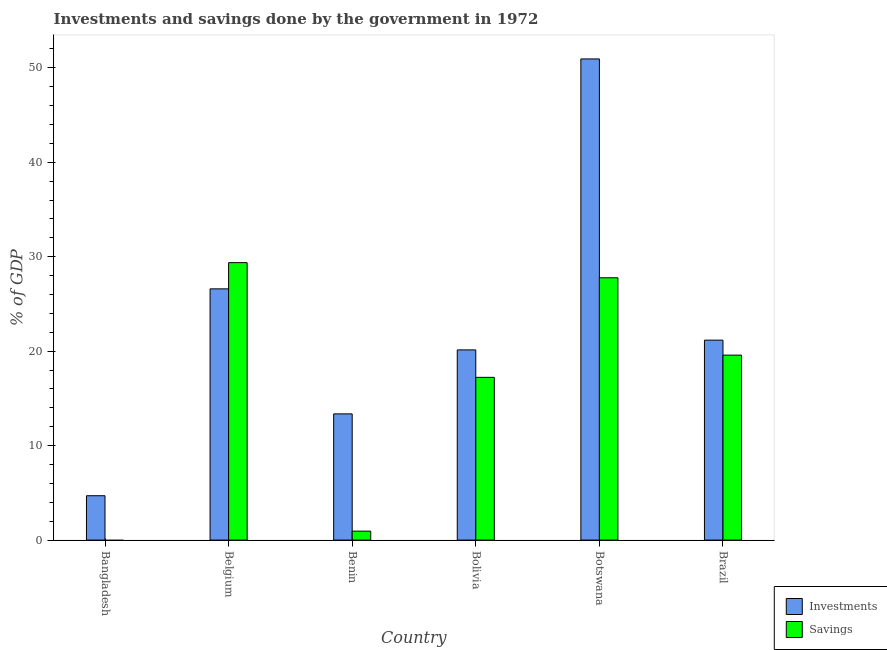How many different coloured bars are there?
Keep it short and to the point. 2. Are the number of bars per tick equal to the number of legend labels?
Your answer should be very brief. No. How many bars are there on the 4th tick from the left?
Keep it short and to the point. 2. How many bars are there on the 1st tick from the right?
Give a very brief answer. 2. What is the label of the 1st group of bars from the left?
Your answer should be compact. Bangladesh. What is the savings of government in Bolivia?
Offer a terse response. 17.23. Across all countries, what is the maximum savings of government?
Provide a short and direct response. 29.38. Across all countries, what is the minimum savings of government?
Give a very brief answer. 0. In which country was the savings of government maximum?
Provide a short and direct response. Belgium. What is the total investments of government in the graph?
Ensure brevity in your answer.  136.91. What is the difference between the investments of government in Bangladesh and that in Belgium?
Provide a short and direct response. -21.9. What is the difference between the investments of government in Brazil and the savings of government in Benin?
Your response must be concise. 20.22. What is the average savings of government per country?
Provide a succinct answer. 15.82. What is the difference between the investments of government and savings of government in Botswana?
Provide a short and direct response. 23.17. What is the ratio of the investments of government in Bangladesh to that in Bolivia?
Offer a very short reply. 0.23. Is the savings of government in Bolivia less than that in Brazil?
Provide a succinct answer. Yes. What is the difference between the highest and the second highest investments of government?
Provide a short and direct response. 24.34. What is the difference between the highest and the lowest investments of government?
Make the answer very short. 46.25. In how many countries, is the savings of government greater than the average savings of government taken over all countries?
Keep it short and to the point. 4. Is the sum of the savings of government in Bolivia and Botswana greater than the maximum investments of government across all countries?
Offer a terse response. No. Are all the bars in the graph horizontal?
Your response must be concise. No. How many countries are there in the graph?
Your answer should be compact. 6. Are the values on the major ticks of Y-axis written in scientific E-notation?
Your answer should be compact. No. Does the graph contain any zero values?
Provide a succinct answer. Yes. Does the graph contain grids?
Make the answer very short. No. What is the title of the graph?
Ensure brevity in your answer.  Investments and savings done by the government in 1972. What is the label or title of the X-axis?
Your response must be concise. Country. What is the label or title of the Y-axis?
Provide a short and direct response. % of GDP. What is the % of GDP of Investments in Bangladesh?
Offer a very short reply. 4.7. What is the % of GDP in Investments in Belgium?
Your answer should be compact. 26.6. What is the % of GDP of Savings in Belgium?
Your answer should be very brief. 29.38. What is the % of GDP of Investments in Benin?
Give a very brief answer. 13.36. What is the % of GDP in Savings in Benin?
Give a very brief answer. 0.95. What is the % of GDP in Investments in Bolivia?
Make the answer very short. 20.14. What is the % of GDP of Savings in Bolivia?
Make the answer very short. 17.23. What is the % of GDP of Investments in Botswana?
Keep it short and to the point. 50.94. What is the % of GDP of Savings in Botswana?
Provide a short and direct response. 27.77. What is the % of GDP of Investments in Brazil?
Your answer should be compact. 21.17. What is the % of GDP of Savings in Brazil?
Keep it short and to the point. 19.59. Across all countries, what is the maximum % of GDP in Investments?
Provide a succinct answer. 50.94. Across all countries, what is the maximum % of GDP in Savings?
Keep it short and to the point. 29.38. Across all countries, what is the minimum % of GDP of Investments?
Offer a terse response. 4.7. Across all countries, what is the minimum % of GDP of Savings?
Your response must be concise. 0. What is the total % of GDP of Investments in the graph?
Ensure brevity in your answer.  136.91. What is the total % of GDP in Savings in the graph?
Your answer should be compact. 94.91. What is the difference between the % of GDP in Investments in Bangladesh and that in Belgium?
Keep it short and to the point. -21.9. What is the difference between the % of GDP in Investments in Bangladesh and that in Benin?
Keep it short and to the point. -8.67. What is the difference between the % of GDP of Investments in Bangladesh and that in Bolivia?
Your answer should be compact. -15.44. What is the difference between the % of GDP of Investments in Bangladesh and that in Botswana?
Make the answer very short. -46.25. What is the difference between the % of GDP in Investments in Bangladesh and that in Brazil?
Ensure brevity in your answer.  -16.47. What is the difference between the % of GDP in Investments in Belgium and that in Benin?
Your response must be concise. 13.24. What is the difference between the % of GDP in Savings in Belgium and that in Benin?
Offer a terse response. 28.43. What is the difference between the % of GDP in Investments in Belgium and that in Bolivia?
Ensure brevity in your answer.  6.46. What is the difference between the % of GDP of Savings in Belgium and that in Bolivia?
Offer a terse response. 12.15. What is the difference between the % of GDP in Investments in Belgium and that in Botswana?
Your answer should be very brief. -24.34. What is the difference between the % of GDP of Savings in Belgium and that in Botswana?
Give a very brief answer. 1.6. What is the difference between the % of GDP in Investments in Belgium and that in Brazil?
Offer a terse response. 5.43. What is the difference between the % of GDP in Savings in Belgium and that in Brazil?
Make the answer very short. 9.79. What is the difference between the % of GDP in Investments in Benin and that in Bolivia?
Your response must be concise. -6.77. What is the difference between the % of GDP in Savings in Benin and that in Bolivia?
Provide a short and direct response. -16.28. What is the difference between the % of GDP of Investments in Benin and that in Botswana?
Ensure brevity in your answer.  -37.58. What is the difference between the % of GDP in Savings in Benin and that in Botswana?
Keep it short and to the point. -26.83. What is the difference between the % of GDP of Investments in Benin and that in Brazil?
Your response must be concise. -7.81. What is the difference between the % of GDP in Savings in Benin and that in Brazil?
Provide a short and direct response. -18.64. What is the difference between the % of GDP in Investments in Bolivia and that in Botswana?
Provide a succinct answer. -30.81. What is the difference between the % of GDP in Savings in Bolivia and that in Botswana?
Your answer should be very brief. -10.54. What is the difference between the % of GDP of Investments in Bolivia and that in Brazil?
Your answer should be compact. -1.03. What is the difference between the % of GDP of Savings in Bolivia and that in Brazil?
Provide a succinct answer. -2.36. What is the difference between the % of GDP in Investments in Botswana and that in Brazil?
Provide a succinct answer. 29.77. What is the difference between the % of GDP of Savings in Botswana and that in Brazil?
Your response must be concise. 8.19. What is the difference between the % of GDP of Investments in Bangladesh and the % of GDP of Savings in Belgium?
Offer a terse response. -24.68. What is the difference between the % of GDP in Investments in Bangladesh and the % of GDP in Savings in Benin?
Give a very brief answer. 3.75. What is the difference between the % of GDP of Investments in Bangladesh and the % of GDP of Savings in Bolivia?
Your answer should be very brief. -12.53. What is the difference between the % of GDP of Investments in Bangladesh and the % of GDP of Savings in Botswana?
Your response must be concise. -23.08. What is the difference between the % of GDP of Investments in Bangladesh and the % of GDP of Savings in Brazil?
Keep it short and to the point. -14.89. What is the difference between the % of GDP in Investments in Belgium and the % of GDP in Savings in Benin?
Keep it short and to the point. 25.65. What is the difference between the % of GDP of Investments in Belgium and the % of GDP of Savings in Bolivia?
Make the answer very short. 9.37. What is the difference between the % of GDP of Investments in Belgium and the % of GDP of Savings in Botswana?
Give a very brief answer. -1.17. What is the difference between the % of GDP of Investments in Belgium and the % of GDP of Savings in Brazil?
Your response must be concise. 7.01. What is the difference between the % of GDP of Investments in Benin and the % of GDP of Savings in Bolivia?
Make the answer very short. -3.87. What is the difference between the % of GDP in Investments in Benin and the % of GDP in Savings in Botswana?
Offer a terse response. -14.41. What is the difference between the % of GDP of Investments in Benin and the % of GDP of Savings in Brazil?
Offer a terse response. -6.22. What is the difference between the % of GDP in Investments in Bolivia and the % of GDP in Savings in Botswana?
Provide a succinct answer. -7.64. What is the difference between the % of GDP in Investments in Bolivia and the % of GDP in Savings in Brazil?
Your answer should be very brief. 0.55. What is the difference between the % of GDP in Investments in Botswana and the % of GDP in Savings in Brazil?
Keep it short and to the point. 31.36. What is the average % of GDP of Investments per country?
Make the answer very short. 22.82. What is the average % of GDP in Savings per country?
Keep it short and to the point. 15.82. What is the difference between the % of GDP in Investments and % of GDP in Savings in Belgium?
Your answer should be compact. -2.78. What is the difference between the % of GDP in Investments and % of GDP in Savings in Benin?
Your answer should be very brief. 12.42. What is the difference between the % of GDP of Investments and % of GDP of Savings in Bolivia?
Provide a short and direct response. 2.91. What is the difference between the % of GDP in Investments and % of GDP in Savings in Botswana?
Provide a succinct answer. 23.17. What is the difference between the % of GDP in Investments and % of GDP in Savings in Brazil?
Give a very brief answer. 1.58. What is the ratio of the % of GDP of Investments in Bangladesh to that in Belgium?
Your answer should be very brief. 0.18. What is the ratio of the % of GDP in Investments in Bangladesh to that in Benin?
Your answer should be very brief. 0.35. What is the ratio of the % of GDP of Investments in Bangladesh to that in Bolivia?
Provide a succinct answer. 0.23. What is the ratio of the % of GDP of Investments in Bangladesh to that in Botswana?
Your answer should be very brief. 0.09. What is the ratio of the % of GDP in Investments in Bangladesh to that in Brazil?
Your answer should be compact. 0.22. What is the ratio of the % of GDP of Investments in Belgium to that in Benin?
Your answer should be compact. 1.99. What is the ratio of the % of GDP in Savings in Belgium to that in Benin?
Your response must be concise. 30.99. What is the ratio of the % of GDP of Investments in Belgium to that in Bolivia?
Keep it short and to the point. 1.32. What is the ratio of the % of GDP in Savings in Belgium to that in Bolivia?
Offer a very short reply. 1.7. What is the ratio of the % of GDP of Investments in Belgium to that in Botswana?
Your answer should be compact. 0.52. What is the ratio of the % of GDP of Savings in Belgium to that in Botswana?
Provide a short and direct response. 1.06. What is the ratio of the % of GDP in Investments in Belgium to that in Brazil?
Give a very brief answer. 1.26. What is the ratio of the % of GDP of Savings in Belgium to that in Brazil?
Provide a succinct answer. 1.5. What is the ratio of the % of GDP in Investments in Benin to that in Bolivia?
Your response must be concise. 0.66. What is the ratio of the % of GDP of Savings in Benin to that in Bolivia?
Keep it short and to the point. 0.06. What is the ratio of the % of GDP of Investments in Benin to that in Botswana?
Keep it short and to the point. 0.26. What is the ratio of the % of GDP in Savings in Benin to that in Botswana?
Make the answer very short. 0.03. What is the ratio of the % of GDP of Investments in Benin to that in Brazil?
Your answer should be very brief. 0.63. What is the ratio of the % of GDP in Savings in Benin to that in Brazil?
Offer a terse response. 0.05. What is the ratio of the % of GDP in Investments in Bolivia to that in Botswana?
Your answer should be very brief. 0.4. What is the ratio of the % of GDP in Savings in Bolivia to that in Botswana?
Keep it short and to the point. 0.62. What is the ratio of the % of GDP in Investments in Bolivia to that in Brazil?
Provide a short and direct response. 0.95. What is the ratio of the % of GDP of Savings in Bolivia to that in Brazil?
Offer a terse response. 0.88. What is the ratio of the % of GDP of Investments in Botswana to that in Brazil?
Provide a succinct answer. 2.41. What is the ratio of the % of GDP of Savings in Botswana to that in Brazil?
Keep it short and to the point. 1.42. What is the difference between the highest and the second highest % of GDP in Investments?
Provide a short and direct response. 24.34. What is the difference between the highest and the second highest % of GDP in Savings?
Provide a short and direct response. 1.6. What is the difference between the highest and the lowest % of GDP of Investments?
Keep it short and to the point. 46.25. What is the difference between the highest and the lowest % of GDP in Savings?
Provide a succinct answer. 29.38. 